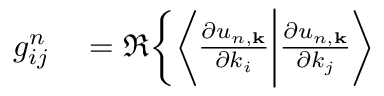<formula> <loc_0><loc_0><loc_500><loc_500>\begin{array} { r l } { g _ { i j } ^ { n } } & = \Re \Big \{ \Big \langle \frac { \partial u _ { n , k } } { \partial k _ { i } } \Big | \frac { \partial u _ { n , k } } { \partial k _ { j } } \Big \rangle } \end{array}</formula> 